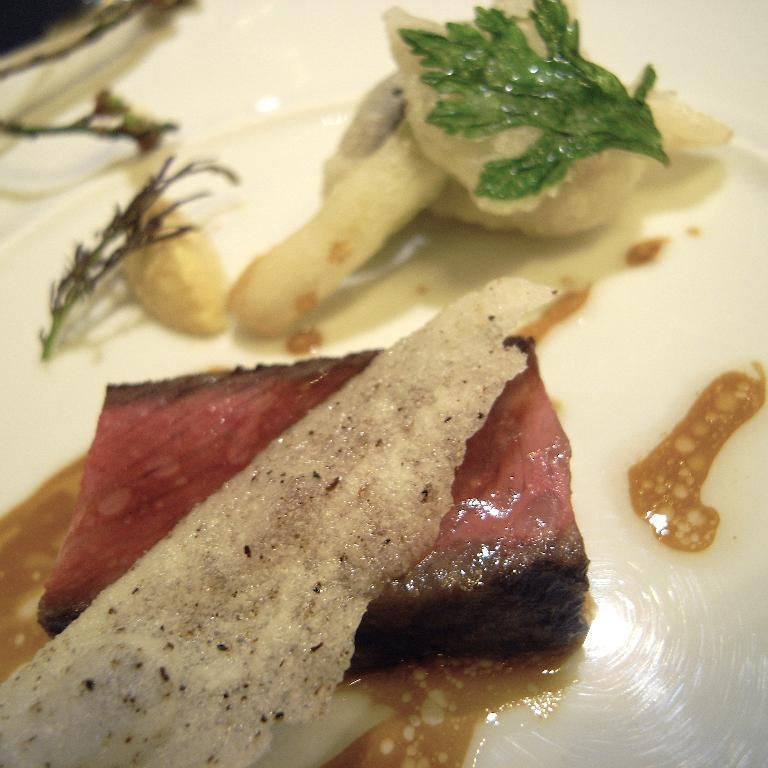What object can be seen in the image that might be used for serving or holding food? There is a plate in the image. What is on the plate in the image? There is food present in the plate. What grade does the food on the plate receive for its presentation? There is no indication of a grade or rating for the food's presentation in the image. 